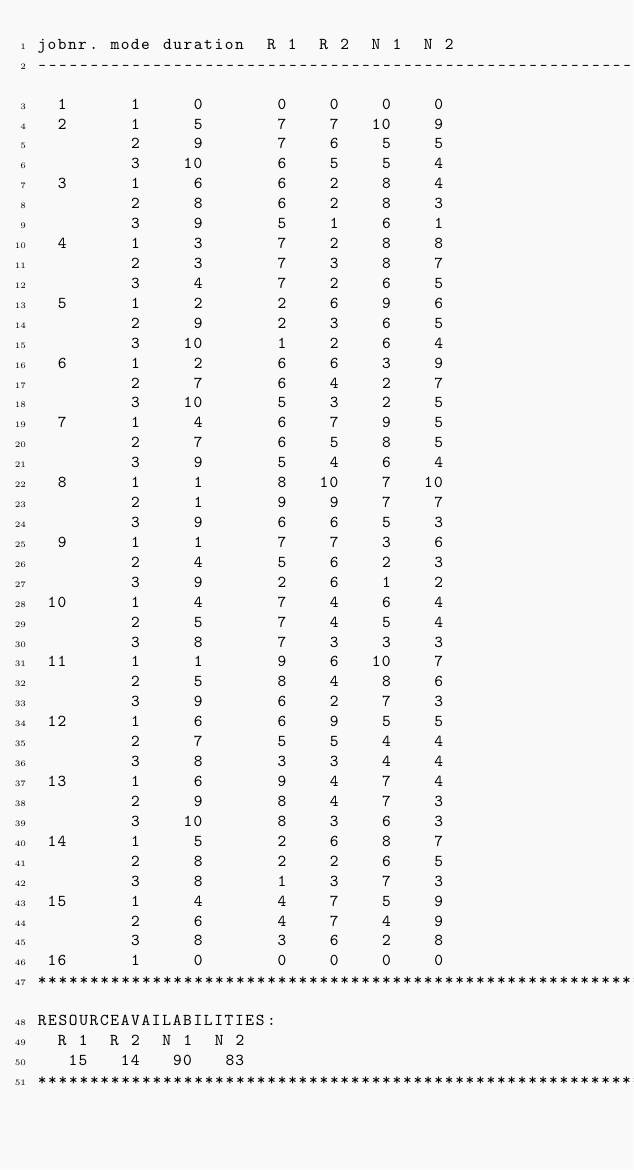Convert code to text. <code><loc_0><loc_0><loc_500><loc_500><_ObjectiveC_>jobnr. mode duration  R 1  R 2  N 1  N 2
------------------------------------------------------------------------
  1      1     0       0    0    0    0
  2      1     5       7    7   10    9
         2     9       7    6    5    5
         3    10       6    5    5    4
  3      1     6       6    2    8    4
         2     8       6    2    8    3
         3     9       5    1    6    1
  4      1     3       7    2    8    8
         2     3       7    3    8    7
         3     4       7    2    6    5
  5      1     2       2    6    9    6
         2     9       2    3    6    5
         3    10       1    2    6    4
  6      1     2       6    6    3    9
         2     7       6    4    2    7
         3    10       5    3    2    5
  7      1     4       6    7    9    5
         2     7       6    5    8    5
         3     9       5    4    6    4
  8      1     1       8   10    7   10
         2     1       9    9    7    7
         3     9       6    6    5    3
  9      1     1       7    7    3    6
         2     4       5    6    2    3
         3     9       2    6    1    2
 10      1     4       7    4    6    4
         2     5       7    4    5    4
         3     8       7    3    3    3
 11      1     1       9    6   10    7
         2     5       8    4    8    6
         3     9       6    2    7    3
 12      1     6       6    9    5    5
         2     7       5    5    4    4
         3     8       3    3    4    4
 13      1     6       9    4    7    4
         2     9       8    4    7    3
         3    10       8    3    6    3
 14      1     5       2    6    8    7
         2     8       2    2    6    5
         3     8       1    3    7    3
 15      1     4       4    7    5    9
         2     6       4    7    4    9
         3     8       3    6    2    8
 16      1     0       0    0    0    0
************************************************************************
RESOURCEAVAILABILITIES:
  R 1  R 2  N 1  N 2
   15   14   90   83
************************************************************************
</code> 